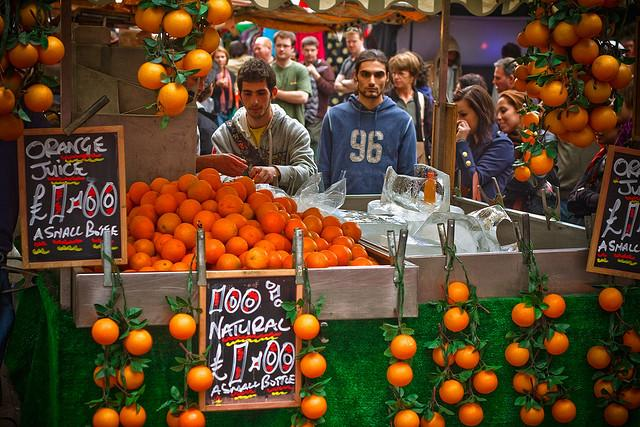What are they waiting in line for?

Choices:
A) buy juice
B) pick oranges
C) exit
D) sell juice buy juice 